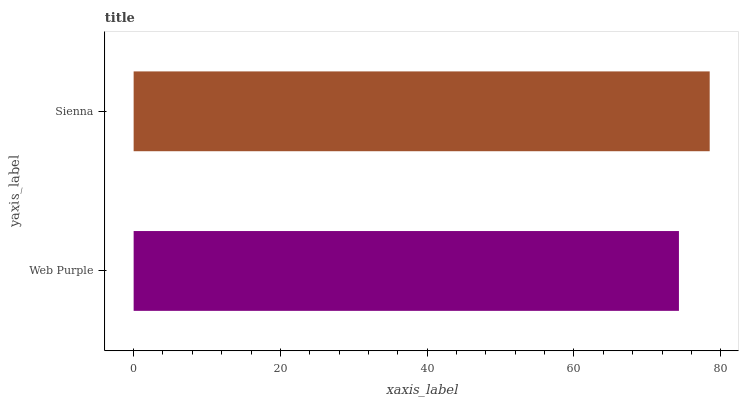Is Web Purple the minimum?
Answer yes or no. Yes. Is Sienna the maximum?
Answer yes or no. Yes. Is Sienna the minimum?
Answer yes or no. No. Is Sienna greater than Web Purple?
Answer yes or no. Yes. Is Web Purple less than Sienna?
Answer yes or no. Yes. Is Web Purple greater than Sienna?
Answer yes or no. No. Is Sienna less than Web Purple?
Answer yes or no. No. Is Sienna the high median?
Answer yes or no. Yes. Is Web Purple the low median?
Answer yes or no. Yes. Is Web Purple the high median?
Answer yes or no. No. Is Sienna the low median?
Answer yes or no. No. 